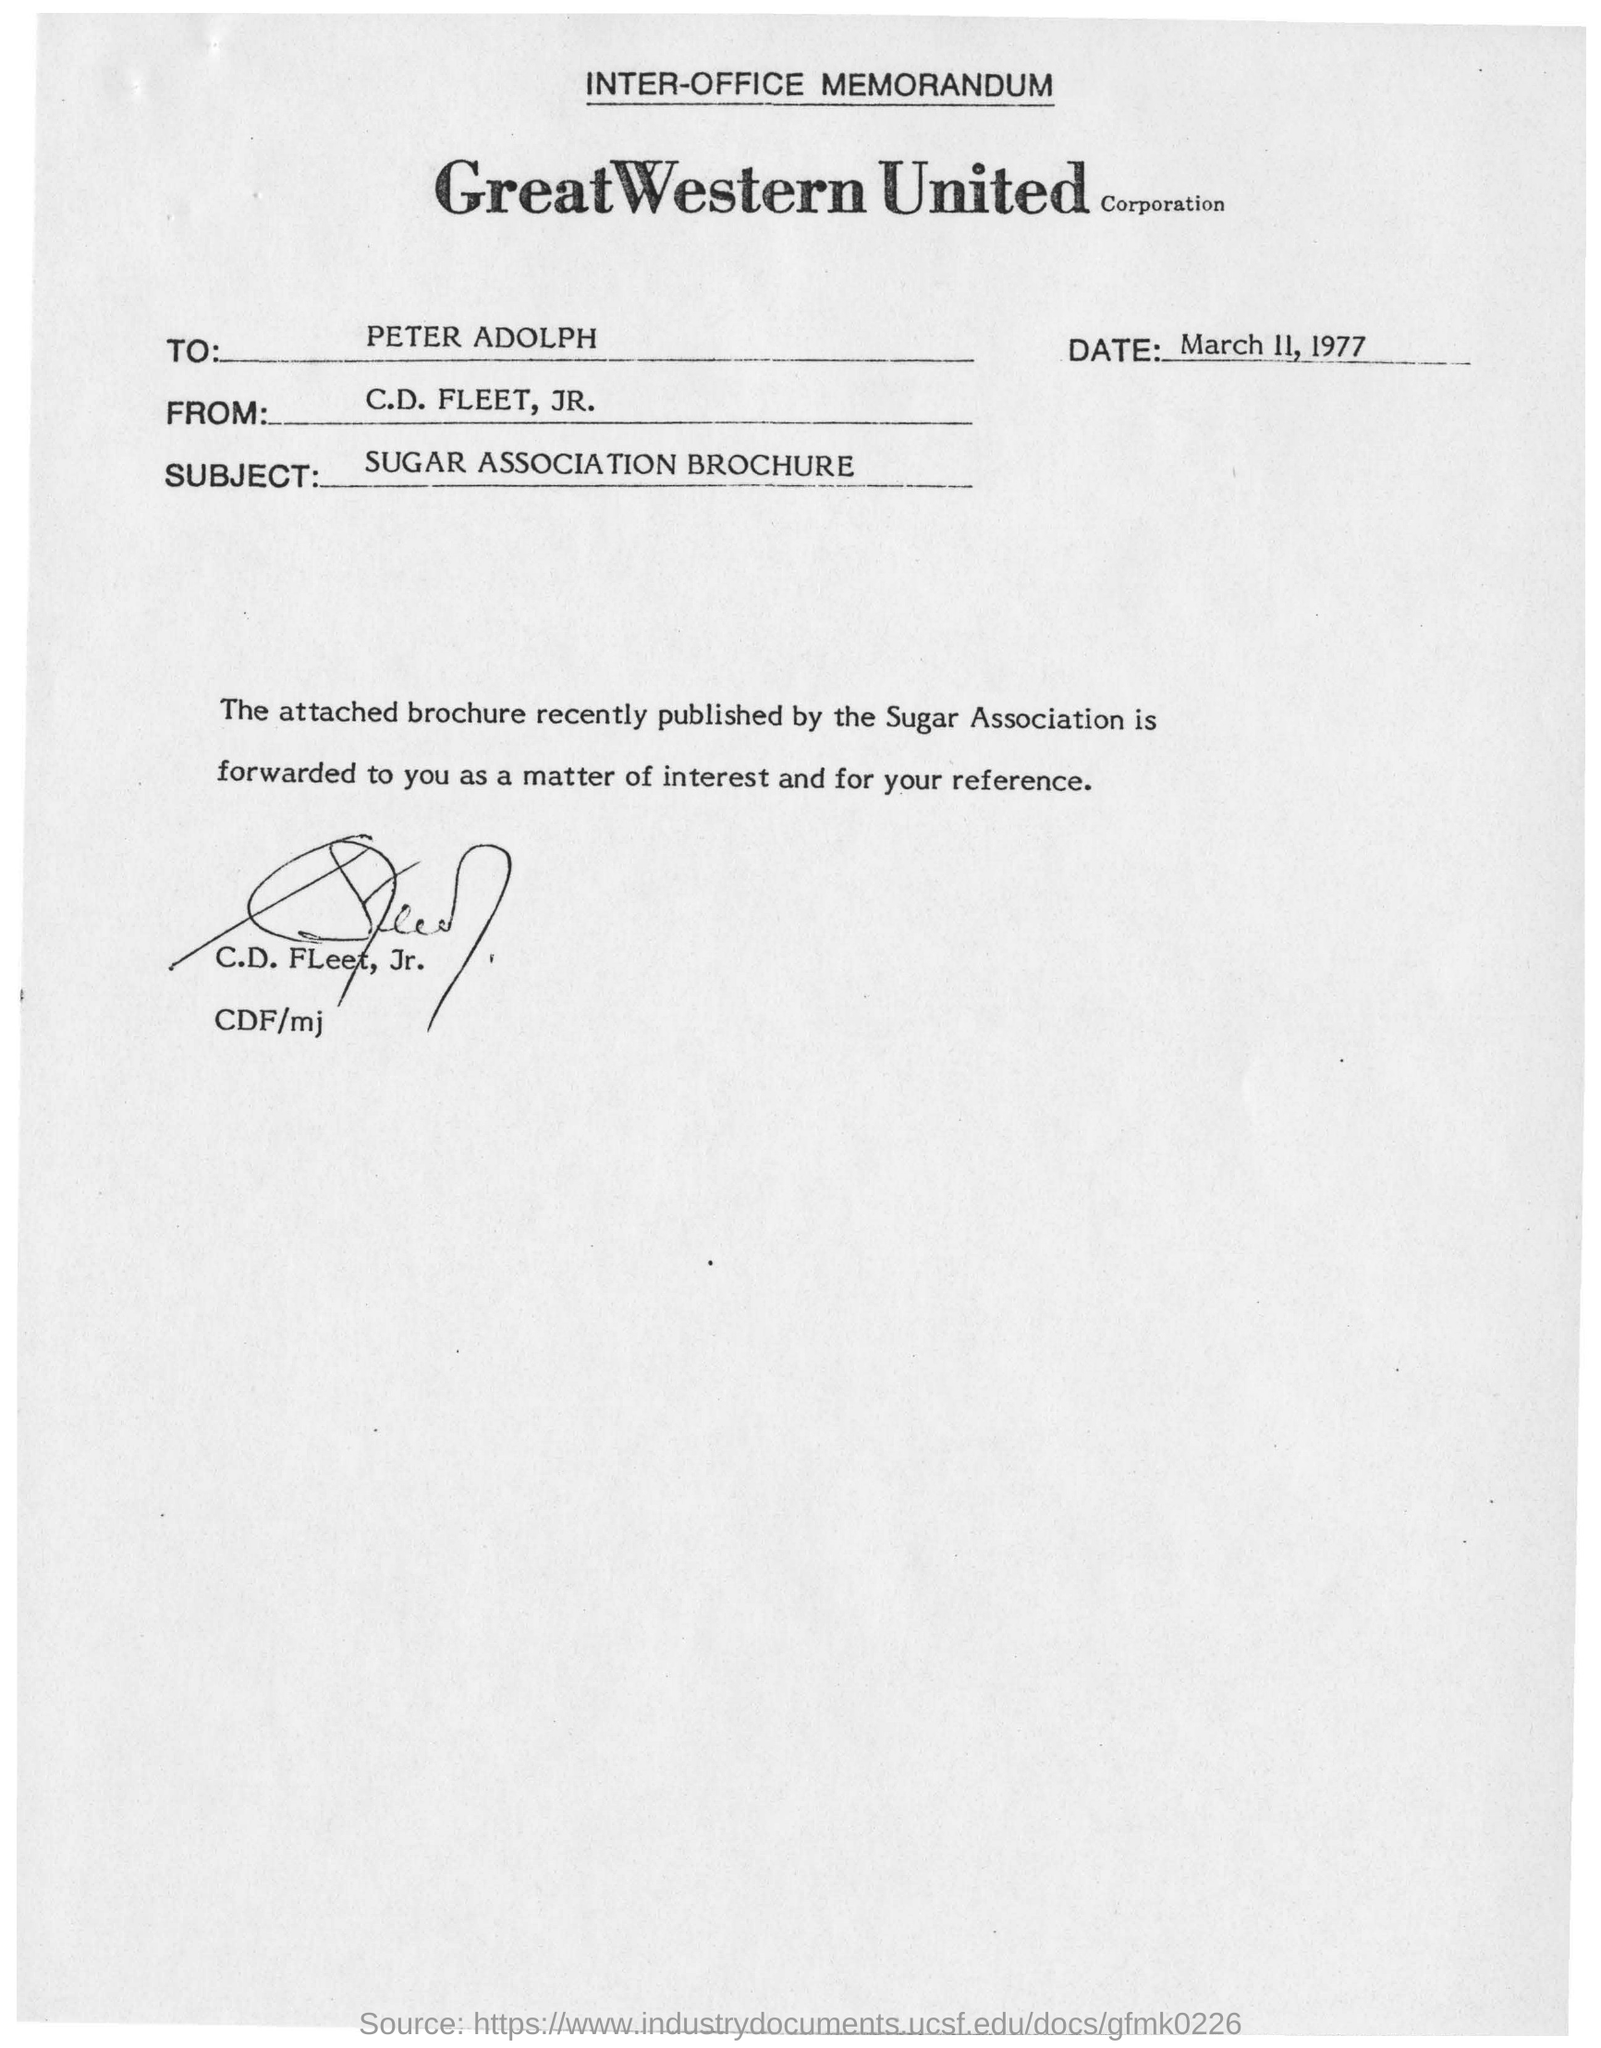From whom the memorandum is sent
Give a very brief answer. C.D. FLEET, JR. To Whom is this memorandum addressed to?
Give a very brief answer. PETER ADOLPH. When is the memorandum dated on?
Make the answer very short. March 11, 1977. 